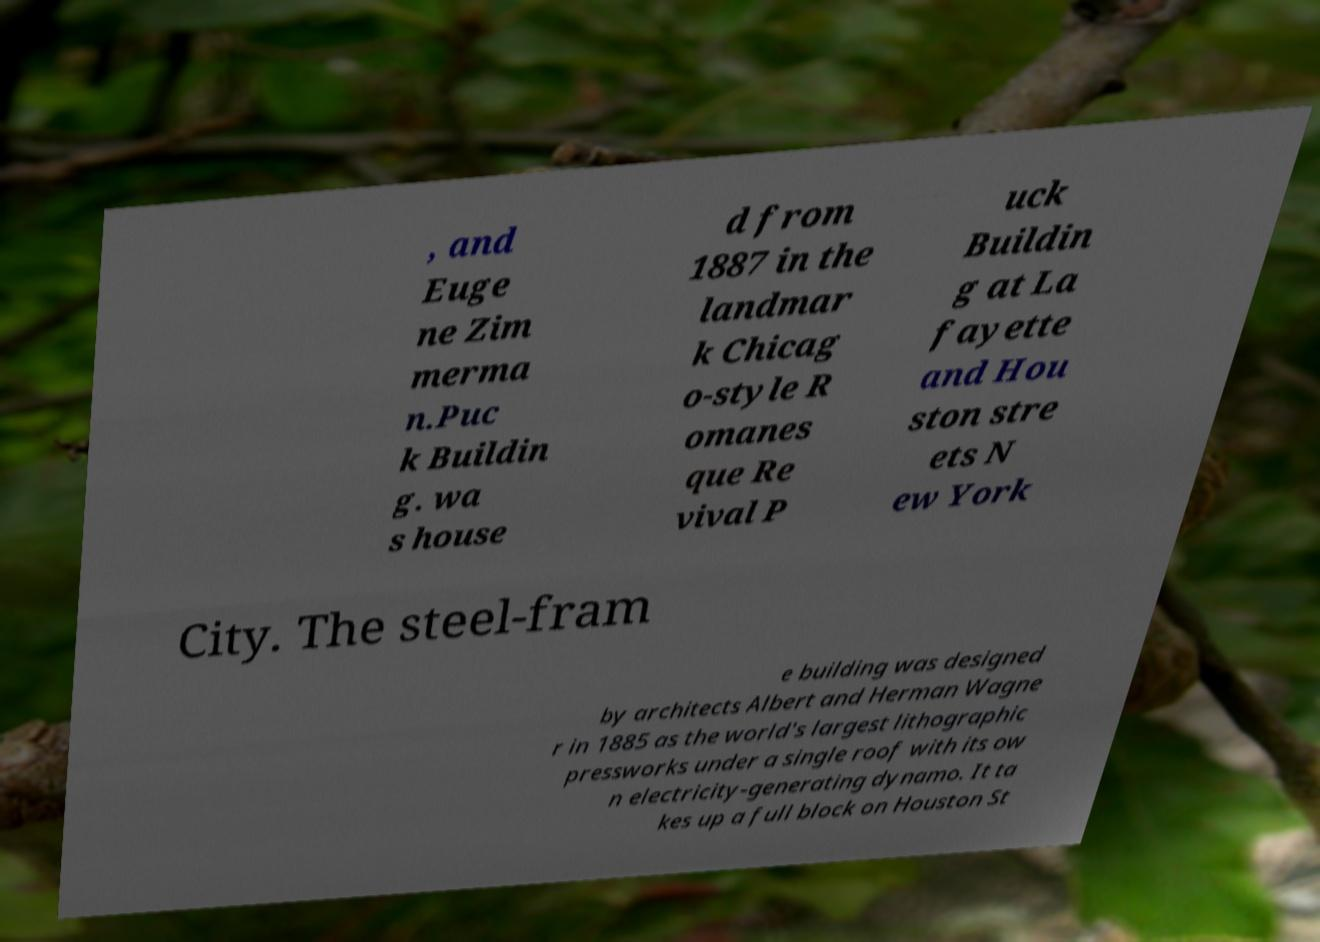Could you assist in decoding the text presented in this image and type it out clearly? , and Euge ne Zim merma n.Puc k Buildin g. wa s house d from 1887 in the landmar k Chicag o-style R omanes que Re vival P uck Buildin g at La fayette and Hou ston stre ets N ew York City. The steel-fram e building was designed by architects Albert and Herman Wagne r in 1885 as the world's largest lithographic pressworks under a single roof with its ow n electricity-generating dynamo. It ta kes up a full block on Houston St 